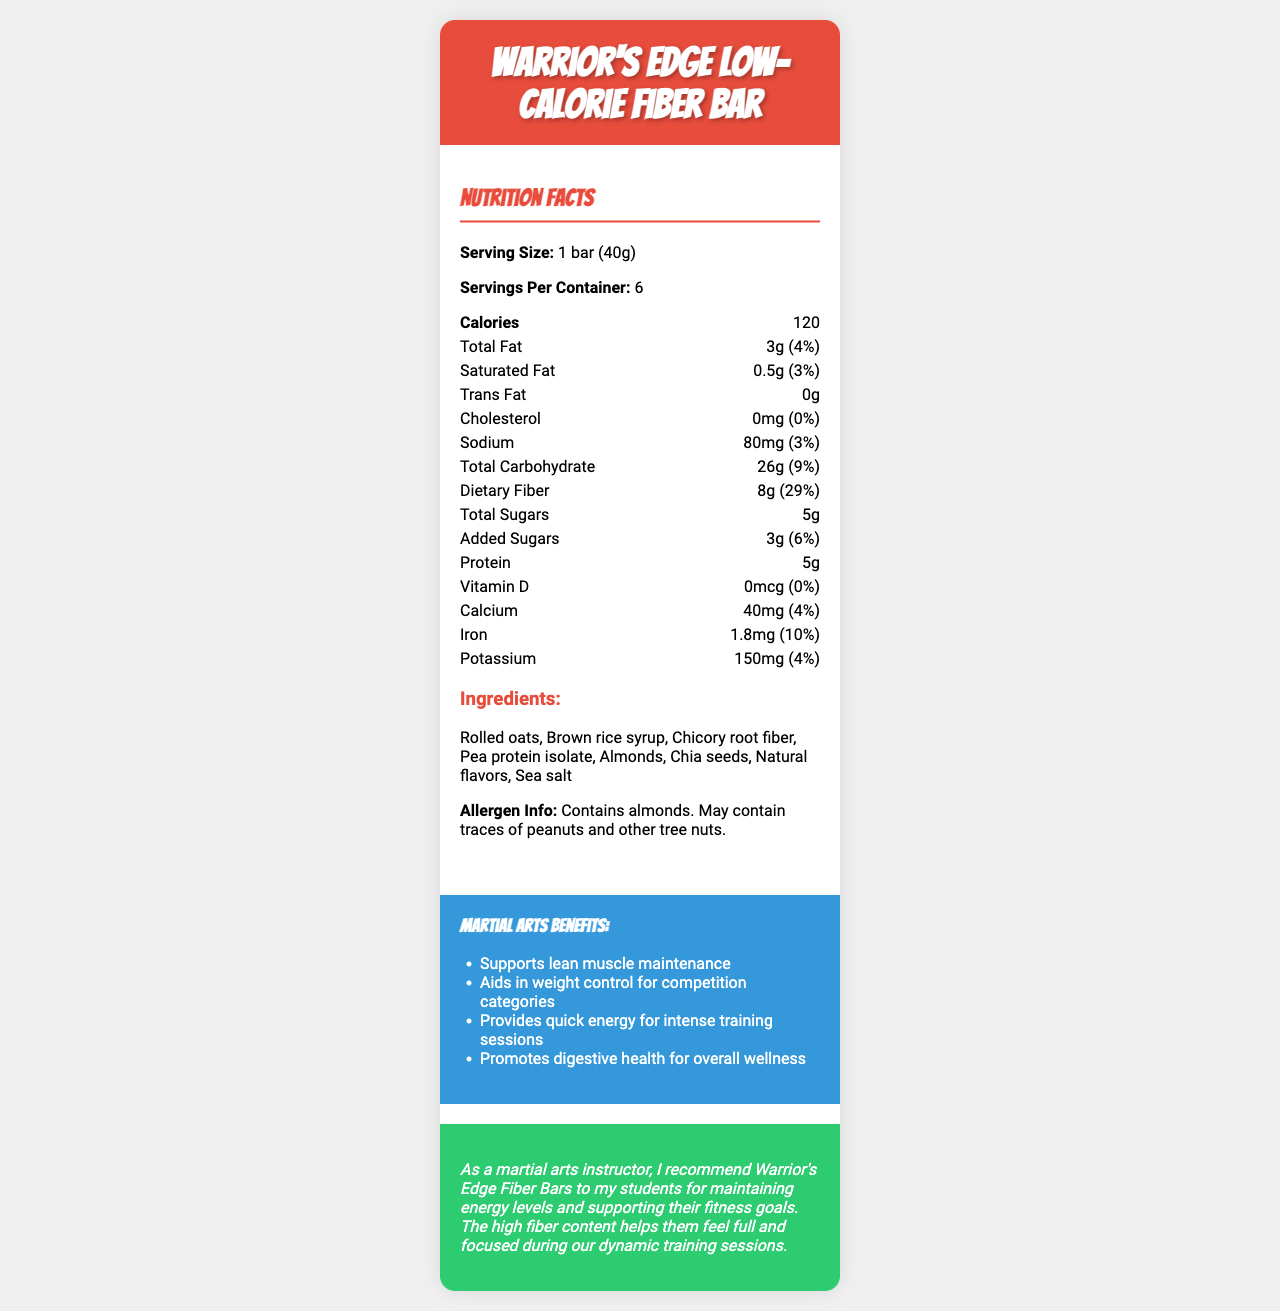what is the serving size? The serving size is clearly mentioned near the top of the document under the Nutrition Facts section.
Answer: 1 bar (40g) how many calories are in one serving of the Warrior's Edge Low-Calorie Fiber Bar? The calorie count can be directly found in the Nutrition Facts section of the document.
Answer: 120 what percentage of daily value does the dietary fiber in one bar contribute? The daily value percentage for dietary fiber is explicitly mentioned as 29% in the Nutrition Facts.
Answer: 29% which ingredient is the primary source of protein in the Warrior's Edge Low-Calorie Fiber Bar? The primary source of protein can be inferred from the list of ingredients where "Pea protein isolate" is listed.
Answer: Pea protein isolate how many servings are there in one container of Warrior's Edge Low-Calorie Fiber Bar? The number of servings per container is clearly specified in the document.
Answer: 6 what is the amount of iron per serving? The amount of iron is mentioned in the Nutrition Facts as 1.8mg.
Answer: 1.8mg how much potassium is present in one bar? The potassium content per serving is listed as 150mg.
Answer: 150mg how much of the total carbohydrate content consists of dietary fiber? The document shows that the total carbohydrate is 26g, and out of this, 8g is dietary fiber.
Answer: 8g out of 26g which of the following ingredients are listed in the Warrior's Edge Low-Calorie Fiber Bar? A. Peanuts B. Chicory root fiber C. Chocolate chips D. Coconut oil The ingredients listed include Chicory root fiber but do not mention peanuts, chocolate chips, or coconut oil.
Answer: B what is one of the marketing claims made about the Warrior's Edge Low-Calorie Fiber Bar? A. High in protein B. No added sugars C. Low-calorie option for weight management D. Contains chocolate One of the marketing claims clearly listed is "Low-calorie option for weight management".
Answer: C does the Warrior's Edge Low-Calorie Fiber Bar contain any artificial preservatives or colors? The marketing claims section states that there are no artificial preservatives or colors.
Answer: No is this product suitable for individuals with a peanut allergy? According to the allergen info, the bar contains almonds and may also contain traces of peanuts.
Answer: No what are the primary benefits of the Warrior's Edge Low-Calorie Fiber Bar for martial artists? The document lists these specific benefits under martial arts benefits.
Answer: Supports lean muscle maintenance, aids in weight control, provides quick energy, promotes digestive health summarize the main idea of the document? The document showcases the nutritional profile and benefits of the product, emphasizing its usefulness for martial arts practitioners.
Answer: The Warrior's Edge Low-Calorie Fiber Bar is marketed as a high-fiber, low-calorie snack suitable for weight management and enhancing training performance for martial artists. It provides detailed nutritional information, ingredients, marketing claims, and martial arts benefits. is there information about the cost of the Warrior's Edge Low-Calorie Fiber Bar? The document does not provide any information regarding the price of the bar.
Answer: Not enough information 